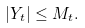Convert formula to latex. <formula><loc_0><loc_0><loc_500><loc_500>\left | Y _ { t } \right | \leq M _ { t } .</formula> 